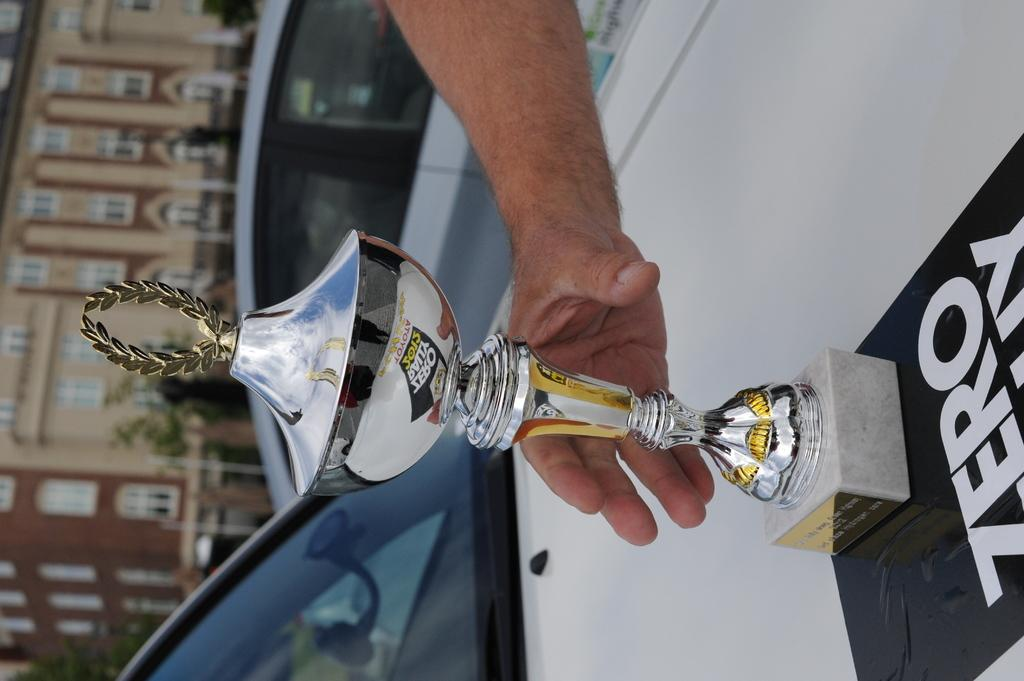What is the main object in the middle of the picture? There is a trophy in the middle of the picture. What else is in the middle of the picture? There is a human hand in the middle of the picture. What can be seen in the background of the picture? There is a building in the background of the picture. How many clouds are visible in the picture? There are no clouds visible in the picture; the background features a building. What day of the week is depicted in the picture? The picture does not depict a specific day of the week; it is a still image. 